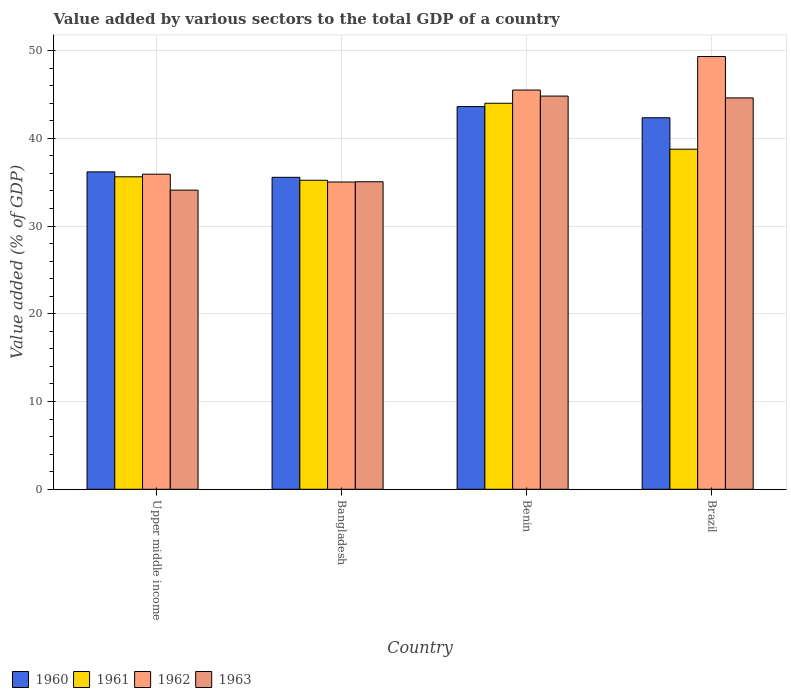How many bars are there on the 2nd tick from the left?
Your answer should be compact. 4. How many bars are there on the 4th tick from the right?
Ensure brevity in your answer.  4. What is the label of the 1st group of bars from the left?
Offer a very short reply. Upper middle income. What is the value added by various sectors to the total GDP in 1961 in Upper middle income?
Your answer should be compact. 35.61. Across all countries, what is the maximum value added by various sectors to the total GDP in 1961?
Your answer should be compact. 43.99. Across all countries, what is the minimum value added by various sectors to the total GDP in 1961?
Your response must be concise. 35.22. In which country was the value added by various sectors to the total GDP in 1961 maximum?
Your answer should be very brief. Benin. In which country was the value added by various sectors to the total GDP in 1963 minimum?
Your answer should be compact. Upper middle income. What is the total value added by various sectors to the total GDP in 1961 in the graph?
Provide a short and direct response. 153.58. What is the difference between the value added by various sectors to the total GDP in 1960 in Bangladesh and that in Benin?
Provide a succinct answer. -8.06. What is the difference between the value added by various sectors to the total GDP in 1962 in Benin and the value added by various sectors to the total GDP in 1963 in Bangladesh?
Offer a very short reply. 10.45. What is the average value added by various sectors to the total GDP in 1963 per country?
Your answer should be compact. 39.64. What is the difference between the value added by various sectors to the total GDP of/in 1960 and value added by various sectors to the total GDP of/in 1961 in Brazil?
Provide a short and direct response. 3.58. In how many countries, is the value added by various sectors to the total GDP in 1962 greater than 2 %?
Ensure brevity in your answer.  4. What is the ratio of the value added by various sectors to the total GDP in 1963 in Bangladesh to that in Benin?
Provide a short and direct response. 0.78. Is the difference between the value added by various sectors to the total GDP in 1960 in Benin and Upper middle income greater than the difference between the value added by various sectors to the total GDP in 1961 in Benin and Upper middle income?
Your answer should be very brief. No. What is the difference between the highest and the second highest value added by various sectors to the total GDP in 1961?
Give a very brief answer. -8.38. What is the difference between the highest and the lowest value added by various sectors to the total GDP in 1960?
Your answer should be very brief. 8.06. In how many countries, is the value added by various sectors to the total GDP in 1960 greater than the average value added by various sectors to the total GDP in 1960 taken over all countries?
Provide a succinct answer. 2. Is the sum of the value added by various sectors to the total GDP in 1962 in Bangladesh and Brazil greater than the maximum value added by various sectors to the total GDP in 1961 across all countries?
Provide a succinct answer. Yes. Is it the case that in every country, the sum of the value added by various sectors to the total GDP in 1963 and value added by various sectors to the total GDP in 1960 is greater than the sum of value added by various sectors to the total GDP in 1961 and value added by various sectors to the total GDP in 1962?
Provide a succinct answer. No. What does the 2nd bar from the left in Benin represents?
Offer a very short reply. 1961. How many bars are there?
Your answer should be compact. 16. Are all the bars in the graph horizontal?
Your answer should be compact. No. What is the difference between two consecutive major ticks on the Y-axis?
Your answer should be compact. 10. Does the graph contain grids?
Offer a terse response. Yes. How many legend labels are there?
Ensure brevity in your answer.  4. How are the legend labels stacked?
Give a very brief answer. Horizontal. What is the title of the graph?
Your answer should be compact. Value added by various sectors to the total GDP of a country. What is the label or title of the Y-axis?
Offer a very short reply. Value added (% of GDP). What is the Value added (% of GDP) in 1960 in Upper middle income?
Keep it short and to the point. 36.17. What is the Value added (% of GDP) in 1961 in Upper middle income?
Provide a succinct answer. 35.61. What is the Value added (% of GDP) in 1962 in Upper middle income?
Make the answer very short. 35.91. What is the Value added (% of GDP) of 1963 in Upper middle income?
Make the answer very short. 34.09. What is the Value added (% of GDP) in 1960 in Bangladesh?
Offer a very short reply. 35.55. What is the Value added (% of GDP) of 1961 in Bangladesh?
Keep it short and to the point. 35.22. What is the Value added (% of GDP) of 1962 in Bangladesh?
Offer a terse response. 35.02. What is the Value added (% of GDP) of 1963 in Bangladesh?
Your response must be concise. 35.05. What is the Value added (% of GDP) in 1960 in Benin?
Give a very brief answer. 43.62. What is the Value added (% of GDP) of 1961 in Benin?
Offer a terse response. 43.99. What is the Value added (% of GDP) of 1962 in Benin?
Make the answer very short. 45.5. What is the Value added (% of GDP) in 1963 in Benin?
Provide a short and direct response. 44.81. What is the Value added (% of GDP) of 1960 in Brazil?
Offer a very short reply. 42.34. What is the Value added (% of GDP) of 1961 in Brazil?
Provide a short and direct response. 38.76. What is the Value added (% of GDP) of 1962 in Brazil?
Your answer should be compact. 49.32. What is the Value added (% of GDP) of 1963 in Brazil?
Keep it short and to the point. 44.6. Across all countries, what is the maximum Value added (% of GDP) in 1960?
Offer a very short reply. 43.62. Across all countries, what is the maximum Value added (% of GDP) in 1961?
Your answer should be compact. 43.99. Across all countries, what is the maximum Value added (% of GDP) in 1962?
Provide a succinct answer. 49.32. Across all countries, what is the maximum Value added (% of GDP) in 1963?
Provide a succinct answer. 44.81. Across all countries, what is the minimum Value added (% of GDP) in 1960?
Make the answer very short. 35.55. Across all countries, what is the minimum Value added (% of GDP) in 1961?
Make the answer very short. 35.22. Across all countries, what is the minimum Value added (% of GDP) in 1962?
Provide a succinct answer. 35.02. Across all countries, what is the minimum Value added (% of GDP) in 1963?
Provide a succinct answer. 34.09. What is the total Value added (% of GDP) in 1960 in the graph?
Offer a terse response. 157.68. What is the total Value added (% of GDP) in 1961 in the graph?
Provide a succinct answer. 153.58. What is the total Value added (% of GDP) of 1962 in the graph?
Your response must be concise. 165.75. What is the total Value added (% of GDP) of 1963 in the graph?
Offer a very short reply. 158.56. What is the difference between the Value added (% of GDP) of 1960 in Upper middle income and that in Bangladesh?
Offer a very short reply. 0.62. What is the difference between the Value added (% of GDP) in 1961 in Upper middle income and that in Bangladesh?
Provide a short and direct response. 0.4. What is the difference between the Value added (% of GDP) in 1962 in Upper middle income and that in Bangladesh?
Your response must be concise. 0.89. What is the difference between the Value added (% of GDP) in 1963 in Upper middle income and that in Bangladesh?
Your answer should be very brief. -0.96. What is the difference between the Value added (% of GDP) of 1960 in Upper middle income and that in Benin?
Give a very brief answer. -7.44. What is the difference between the Value added (% of GDP) in 1961 in Upper middle income and that in Benin?
Provide a short and direct response. -8.38. What is the difference between the Value added (% of GDP) in 1962 in Upper middle income and that in Benin?
Provide a succinct answer. -9.59. What is the difference between the Value added (% of GDP) in 1963 in Upper middle income and that in Benin?
Your answer should be compact. -10.72. What is the difference between the Value added (% of GDP) in 1960 in Upper middle income and that in Brazil?
Give a very brief answer. -6.17. What is the difference between the Value added (% of GDP) of 1961 in Upper middle income and that in Brazil?
Provide a succinct answer. -3.15. What is the difference between the Value added (% of GDP) in 1962 in Upper middle income and that in Brazil?
Keep it short and to the point. -13.41. What is the difference between the Value added (% of GDP) of 1963 in Upper middle income and that in Brazil?
Offer a very short reply. -10.51. What is the difference between the Value added (% of GDP) of 1960 in Bangladesh and that in Benin?
Offer a very short reply. -8.06. What is the difference between the Value added (% of GDP) of 1961 in Bangladesh and that in Benin?
Keep it short and to the point. -8.78. What is the difference between the Value added (% of GDP) in 1962 in Bangladesh and that in Benin?
Make the answer very short. -10.48. What is the difference between the Value added (% of GDP) in 1963 in Bangladesh and that in Benin?
Your response must be concise. -9.76. What is the difference between the Value added (% of GDP) in 1960 in Bangladesh and that in Brazil?
Your answer should be compact. -6.79. What is the difference between the Value added (% of GDP) of 1961 in Bangladesh and that in Brazil?
Offer a very short reply. -3.54. What is the difference between the Value added (% of GDP) of 1962 in Bangladesh and that in Brazil?
Your answer should be very brief. -14.3. What is the difference between the Value added (% of GDP) in 1963 in Bangladesh and that in Brazil?
Offer a very short reply. -9.56. What is the difference between the Value added (% of GDP) of 1960 in Benin and that in Brazil?
Give a very brief answer. 1.27. What is the difference between the Value added (% of GDP) of 1961 in Benin and that in Brazil?
Provide a succinct answer. 5.23. What is the difference between the Value added (% of GDP) of 1962 in Benin and that in Brazil?
Offer a very short reply. -3.82. What is the difference between the Value added (% of GDP) in 1963 in Benin and that in Brazil?
Your response must be concise. 0.21. What is the difference between the Value added (% of GDP) in 1960 in Upper middle income and the Value added (% of GDP) in 1961 in Bangladesh?
Provide a short and direct response. 0.96. What is the difference between the Value added (% of GDP) of 1960 in Upper middle income and the Value added (% of GDP) of 1962 in Bangladesh?
Keep it short and to the point. 1.16. What is the difference between the Value added (% of GDP) of 1960 in Upper middle income and the Value added (% of GDP) of 1963 in Bangladesh?
Your response must be concise. 1.12. What is the difference between the Value added (% of GDP) of 1961 in Upper middle income and the Value added (% of GDP) of 1962 in Bangladesh?
Your answer should be compact. 0.6. What is the difference between the Value added (% of GDP) of 1961 in Upper middle income and the Value added (% of GDP) of 1963 in Bangladesh?
Make the answer very short. 0.56. What is the difference between the Value added (% of GDP) in 1962 in Upper middle income and the Value added (% of GDP) in 1963 in Bangladesh?
Provide a succinct answer. 0.86. What is the difference between the Value added (% of GDP) in 1960 in Upper middle income and the Value added (% of GDP) in 1961 in Benin?
Make the answer very short. -7.82. What is the difference between the Value added (% of GDP) in 1960 in Upper middle income and the Value added (% of GDP) in 1962 in Benin?
Keep it short and to the point. -9.33. What is the difference between the Value added (% of GDP) of 1960 in Upper middle income and the Value added (% of GDP) of 1963 in Benin?
Keep it short and to the point. -8.64. What is the difference between the Value added (% of GDP) of 1961 in Upper middle income and the Value added (% of GDP) of 1962 in Benin?
Provide a short and direct response. -9.89. What is the difference between the Value added (% of GDP) in 1961 in Upper middle income and the Value added (% of GDP) in 1963 in Benin?
Provide a short and direct response. -9.2. What is the difference between the Value added (% of GDP) of 1962 in Upper middle income and the Value added (% of GDP) of 1963 in Benin?
Keep it short and to the point. -8.9. What is the difference between the Value added (% of GDP) of 1960 in Upper middle income and the Value added (% of GDP) of 1961 in Brazil?
Offer a terse response. -2.58. What is the difference between the Value added (% of GDP) in 1960 in Upper middle income and the Value added (% of GDP) in 1962 in Brazil?
Your answer should be very brief. -13.15. What is the difference between the Value added (% of GDP) of 1960 in Upper middle income and the Value added (% of GDP) of 1963 in Brazil?
Offer a very short reply. -8.43. What is the difference between the Value added (% of GDP) of 1961 in Upper middle income and the Value added (% of GDP) of 1962 in Brazil?
Provide a short and direct response. -13.71. What is the difference between the Value added (% of GDP) in 1961 in Upper middle income and the Value added (% of GDP) in 1963 in Brazil?
Provide a succinct answer. -8.99. What is the difference between the Value added (% of GDP) of 1962 in Upper middle income and the Value added (% of GDP) of 1963 in Brazil?
Your response must be concise. -8.69. What is the difference between the Value added (% of GDP) in 1960 in Bangladesh and the Value added (% of GDP) in 1961 in Benin?
Your response must be concise. -8.44. What is the difference between the Value added (% of GDP) of 1960 in Bangladesh and the Value added (% of GDP) of 1962 in Benin?
Provide a succinct answer. -9.95. What is the difference between the Value added (% of GDP) in 1960 in Bangladesh and the Value added (% of GDP) in 1963 in Benin?
Provide a short and direct response. -9.26. What is the difference between the Value added (% of GDP) in 1961 in Bangladesh and the Value added (% of GDP) in 1962 in Benin?
Offer a very short reply. -10.28. What is the difference between the Value added (% of GDP) in 1961 in Bangladesh and the Value added (% of GDP) in 1963 in Benin?
Keep it short and to the point. -9.59. What is the difference between the Value added (% of GDP) of 1962 in Bangladesh and the Value added (% of GDP) of 1963 in Benin?
Your response must be concise. -9.79. What is the difference between the Value added (% of GDP) in 1960 in Bangladesh and the Value added (% of GDP) in 1961 in Brazil?
Offer a very short reply. -3.21. What is the difference between the Value added (% of GDP) in 1960 in Bangladesh and the Value added (% of GDP) in 1962 in Brazil?
Your answer should be very brief. -13.77. What is the difference between the Value added (% of GDP) in 1960 in Bangladesh and the Value added (% of GDP) in 1963 in Brazil?
Ensure brevity in your answer.  -9.05. What is the difference between the Value added (% of GDP) in 1961 in Bangladesh and the Value added (% of GDP) in 1962 in Brazil?
Offer a terse response. -14.1. What is the difference between the Value added (% of GDP) of 1961 in Bangladesh and the Value added (% of GDP) of 1963 in Brazil?
Your answer should be very brief. -9.39. What is the difference between the Value added (% of GDP) in 1962 in Bangladesh and the Value added (% of GDP) in 1963 in Brazil?
Offer a terse response. -9.59. What is the difference between the Value added (% of GDP) in 1960 in Benin and the Value added (% of GDP) in 1961 in Brazil?
Make the answer very short. 4.86. What is the difference between the Value added (% of GDP) in 1960 in Benin and the Value added (% of GDP) in 1962 in Brazil?
Offer a terse response. -5.71. What is the difference between the Value added (% of GDP) in 1960 in Benin and the Value added (% of GDP) in 1963 in Brazil?
Ensure brevity in your answer.  -0.99. What is the difference between the Value added (% of GDP) in 1961 in Benin and the Value added (% of GDP) in 1962 in Brazil?
Offer a terse response. -5.33. What is the difference between the Value added (% of GDP) of 1961 in Benin and the Value added (% of GDP) of 1963 in Brazil?
Your response must be concise. -0.61. What is the difference between the Value added (% of GDP) of 1962 in Benin and the Value added (% of GDP) of 1963 in Brazil?
Ensure brevity in your answer.  0.89. What is the average Value added (% of GDP) in 1960 per country?
Provide a short and direct response. 39.42. What is the average Value added (% of GDP) of 1961 per country?
Your answer should be very brief. 38.4. What is the average Value added (% of GDP) of 1962 per country?
Offer a terse response. 41.44. What is the average Value added (% of GDP) of 1963 per country?
Give a very brief answer. 39.64. What is the difference between the Value added (% of GDP) of 1960 and Value added (% of GDP) of 1961 in Upper middle income?
Offer a terse response. 0.56. What is the difference between the Value added (% of GDP) of 1960 and Value added (% of GDP) of 1962 in Upper middle income?
Offer a terse response. 0.26. What is the difference between the Value added (% of GDP) of 1960 and Value added (% of GDP) of 1963 in Upper middle income?
Ensure brevity in your answer.  2.08. What is the difference between the Value added (% of GDP) in 1961 and Value added (% of GDP) in 1962 in Upper middle income?
Offer a very short reply. -0.3. What is the difference between the Value added (% of GDP) of 1961 and Value added (% of GDP) of 1963 in Upper middle income?
Make the answer very short. 1.52. What is the difference between the Value added (% of GDP) in 1962 and Value added (% of GDP) in 1963 in Upper middle income?
Your answer should be very brief. 1.82. What is the difference between the Value added (% of GDP) of 1960 and Value added (% of GDP) of 1961 in Bangladesh?
Your answer should be compact. 0.33. What is the difference between the Value added (% of GDP) in 1960 and Value added (% of GDP) in 1962 in Bangladesh?
Your response must be concise. 0.53. What is the difference between the Value added (% of GDP) in 1960 and Value added (% of GDP) in 1963 in Bangladesh?
Your answer should be compact. 0.5. What is the difference between the Value added (% of GDP) in 1961 and Value added (% of GDP) in 1962 in Bangladesh?
Your response must be concise. 0.2. What is the difference between the Value added (% of GDP) of 1961 and Value added (% of GDP) of 1963 in Bangladesh?
Keep it short and to the point. 0.17. What is the difference between the Value added (% of GDP) of 1962 and Value added (% of GDP) of 1963 in Bangladesh?
Your answer should be compact. -0.03. What is the difference between the Value added (% of GDP) in 1960 and Value added (% of GDP) in 1961 in Benin?
Make the answer very short. -0.38. What is the difference between the Value added (% of GDP) of 1960 and Value added (% of GDP) of 1962 in Benin?
Give a very brief answer. -1.88. What is the difference between the Value added (% of GDP) of 1960 and Value added (% of GDP) of 1963 in Benin?
Keep it short and to the point. -1.2. What is the difference between the Value added (% of GDP) of 1961 and Value added (% of GDP) of 1962 in Benin?
Provide a short and direct response. -1.51. What is the difference between the Value added (% of GDP) of 1961 and Value added (% of GDP) of 1963 in Benin?
Your response must be concise. -0.82. What is the difference between the Value added (% of GDP) of 1962 and Value added (% of GDP) of 1963 in Benin?
Offer a very short reply. 0.69. What is the difference between the Value added (% of GDP) in 1960 and Value added (% of GDP) in 1961 in Brazil?
Keep it short and to the point. 3.58. What is the difference between the Value added (% of GDP) in 1960 and Value added (% of GDP) in 1962 in Brazil?
Offer a terse response. -6.98. What is the difference between the Value added (% of GDP) of 1960 and Value added (% of GDP) of 1963 in Brazil?
Your answer should be very brief. -2.26. What is the difference between the Value added (% of GDP) of 1961 and Value added (% of GDP) of 1962 in Brazil?
Make the answer very short. -10.56. What is the difference between the Value added (% of GDP) of 1961 and Value added (% of GDP) of 1963 in Brazil?
Provide a short and direct response. -5.85. What is the difference between the Value added (% of GDP) in 1962 and Value added (% of GDP) in 1963 in Brazil?
Provide a succinct answer. 4.72. What is the ratio of the Value added (% of GDP) of 1960 in Upper middle income to that in Bangladesh?
Keep it short and to the point. 1.02. What is the ratio of the Value added (% of GDP) of 1961 in Upper middle income to that in Bangladesh?
Keep it short and to the point. 1.01. What is the ratio of the Value added (% of GDP) of 1962 in Upper middle income to that in Bangladesh?
Give a very brief answer. 1.03. What is the ratio of the Value added (% of GDP) in 1963 in Upper middle income to that in Bangladesh?
Provide a short and direct response. 0.97. What is the ratio of the Value added (% of GDP) of 1960 in Upper middle income to that in Benin?
Provide a succinct answer. 0.83. What is the ratio of the Value added (% of GDP) of 1961 in Upper middle income to that in Benin?
Provide a succinct answer. 0.81. What is the ratio of the Value added (% of GDP) of 1962 in Upper middle income to that in Benin?
Provide a short and direct response. 0.79. What is the ratio of the Value added (% of GDP) of 1963 in Upper middle income to that in Benin?
Make the answer very short. 0.76. What is the ratio of the Value added (% of GDP) in 1960 in Upper middle income to that in Brazil?
Give a very brief answer. 0.85. What is the ratio of the Value added (% of GDP) in 1961 in Upper middle income to that in Brazil?
Your response must be concise. 0.92. What is the ratio of the Value added (% of GDP) of 1962 in Upper middle income to that in Brazil?
Your answer should be very brief. 0.73. What is the ratio of the Value added (% of GDP) of 1963 in Upper middle income to that in Brazil?
Make the answer very short. 0.76. What is the ratio of the Value added (% of GDP) of 1960 in Bangladesh to that in Benin?
Provide a short and direct response. 0.82. What is the ratio of the Value added (% of GDP) of 1961 in Bangladesh to that in Benin?
Your answer should be compact. 0.8. What is the ratio of the Value added (% of GDP) of 1962 in Bangladesh to that in Benin?
Give a very brief answer. 0.77. What is the ratio of the Value added (% of GDP) in 1963 in Bangladesh to that in Benin?
Make the answer very short. 0.78. What is the ratio of the Value added (% of GDP) of 1960 in Bangladesh to that in Brazil?
Your answer should be compact. 0.84. What is the ratio of the Value added (% of GDP) in 1961 in Bangladesh to that in Brazil?
Ensure brevity in your answer.  0.91. What is the ratio of the Value added (% of GDP) in 1962 in Bangladesh to that in Brazil?
Your answer should be compact. 0.71. What is the ratio of the Value added (% of GDP) of 1963 in Bangladesh to that in Brazil?
Make the answer very short. 0.79. What is the ratio of the Value added (% of GDP) in 1960 in Benin to that in Brazil?
Provide a short and direct response. 1.03. What is the ratio of the Value added (% of GDP) of 1961 in Benin to that in Brazil?
Keep it short and to the point. 1.14. What is the ratio of the Value added (% of GDP) of 1962 in Benin to that in Brazil?
Offer a terse response. 0.92. What is the ratio of the Value added (% of GDP) in 1963 in Benin to that in Brazil?
Ensure brevity in your answer.  1. What is the difference between the highest and the second highest Value added (% of GDP) of 1960?
Offer a terse response. 1.27. What is the difference between the highest and the second highest Value added (% of GDP) of 1961?
Offer a very short reply. 5.23. What is the difference between the highest and the second highest Value added (% of GDP) of 1962?
Offer a very short reply. 3.82. What is the difference between the highest and the second highest Value added (% of GDP) of 1963?
Provide a short and direct response. 0.21. What is the difference between the highest and the lowest Value added (% of GDP) of 1960?
Provide a succinct answer. 8.06. What is the difference between the highest and the lowest Value added (% of GDP) of 1961?
Ensure brevity in your answer.  8.78. What is the difference between the highest and the lowest Value added (% of GDP) in 1962?
Your response must be concise. 14.3. What is the difference between the highest and the lowest Value added (% of GDP) of 1963?
Make the answer very short. 10.72. 